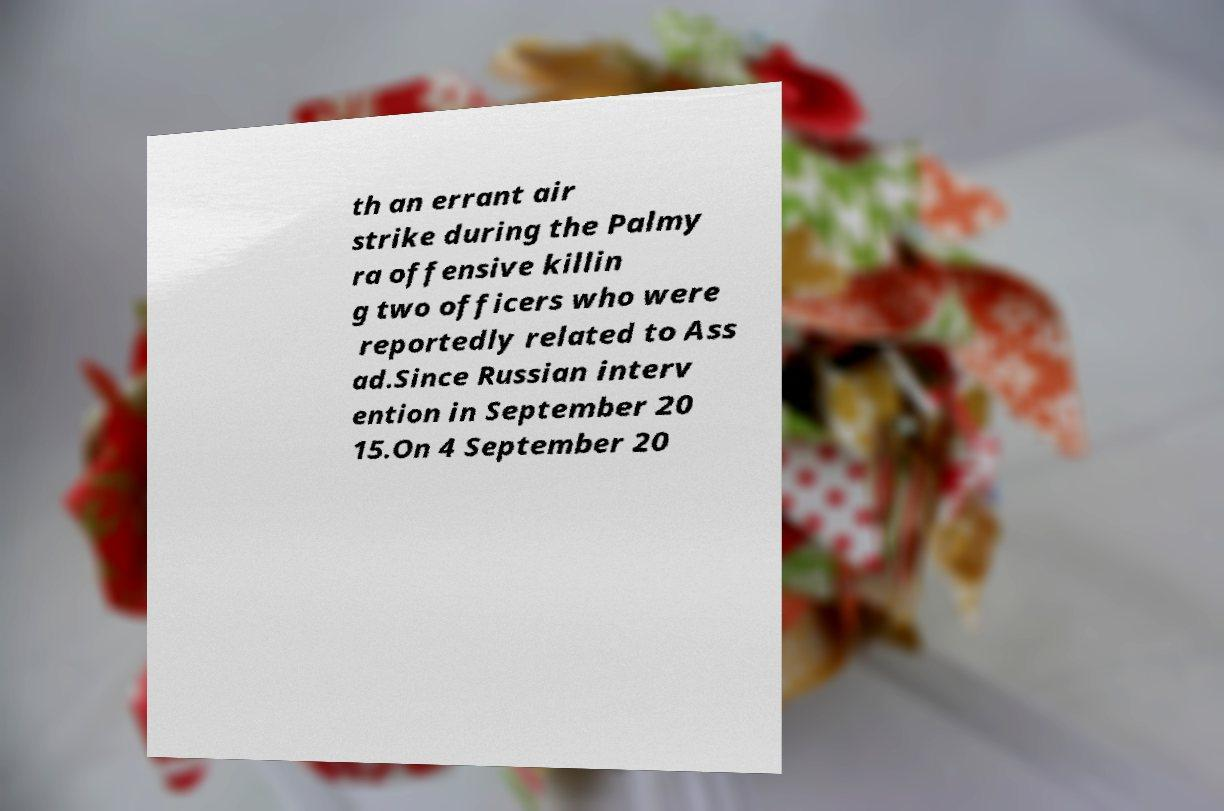For documentation purposes, I need the text within this image transcribed. Could you provide that? th an errant air strike during the Palmy ra offensive killin g two officers who were reportedly related to Ass ad.Since Russian interv ention in September 20 15.On 4 September 20 